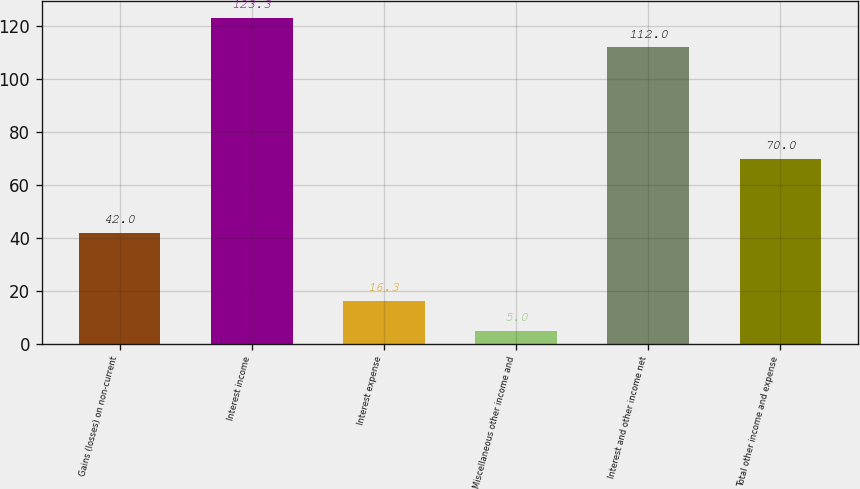Convert chart to OTSL. <chart><loc_0><loc_0><loc_500><loc_500><bar_chart><fcel>Gains (losses) on non-current<fcel>Interest income<fcel>Interest expense<fcel>Miscellaneous other income and<fcel>Interest and other income net<fcel>Total other income and expense<nl><fcel>42<fcel>123.3<fcel>16.3<fcel>5<fcel>112<fcel>70<nl></chart> 